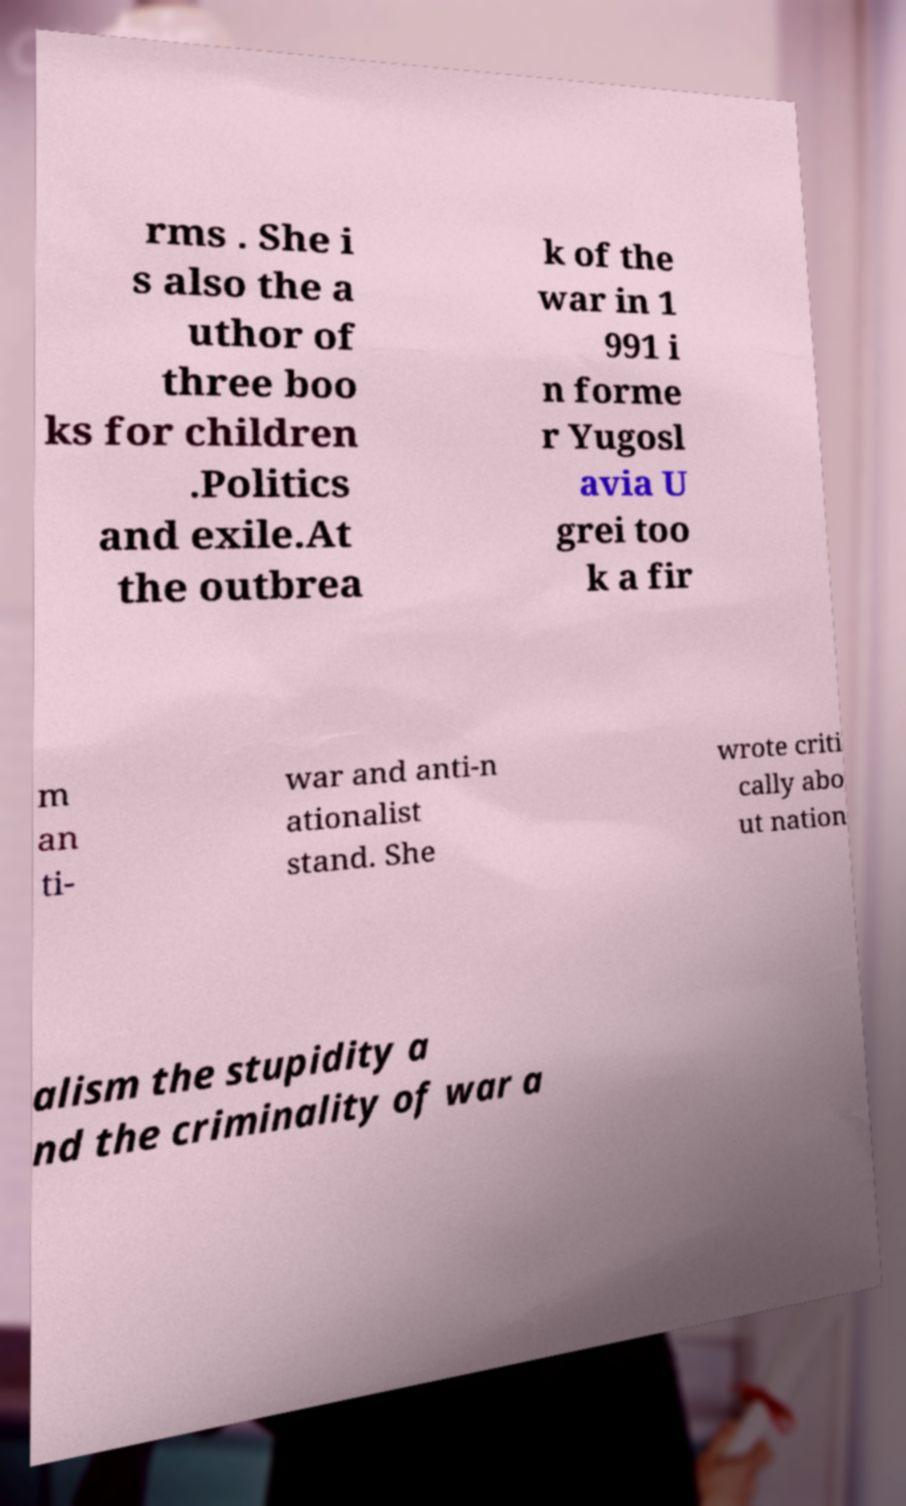Can you accurately transcribe the text from the provided image for me? rms . She i s also the a uthor of three boo ks for children .Politics and exile.At the outbrea k of the war in 1 991 i n forme r Yugosl avia U grei too k a fir m an ti- war and anti-n ationalist stand. She wrote criti cally abo ut nation alism the stupidity a nd the criminality of war a 